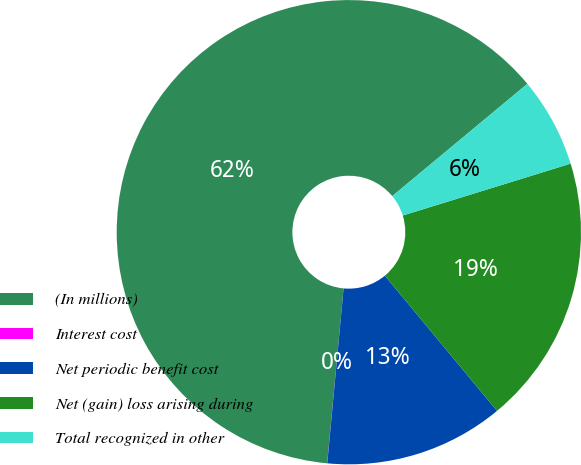<chart> <loc_0><loc_0><loc_500><loc_500><pie_chart><fcel>(In millions)<fcel>Interest cost<fcel>Net periodic benefit cost<fcel>Net (gain) loss arising during<fcel>Total recognized in other<nl><fcel>62.47%<fcel>0.01%<fcel>12.5%<fcel>18.75%<fcel>6.26%<nl></chart> 